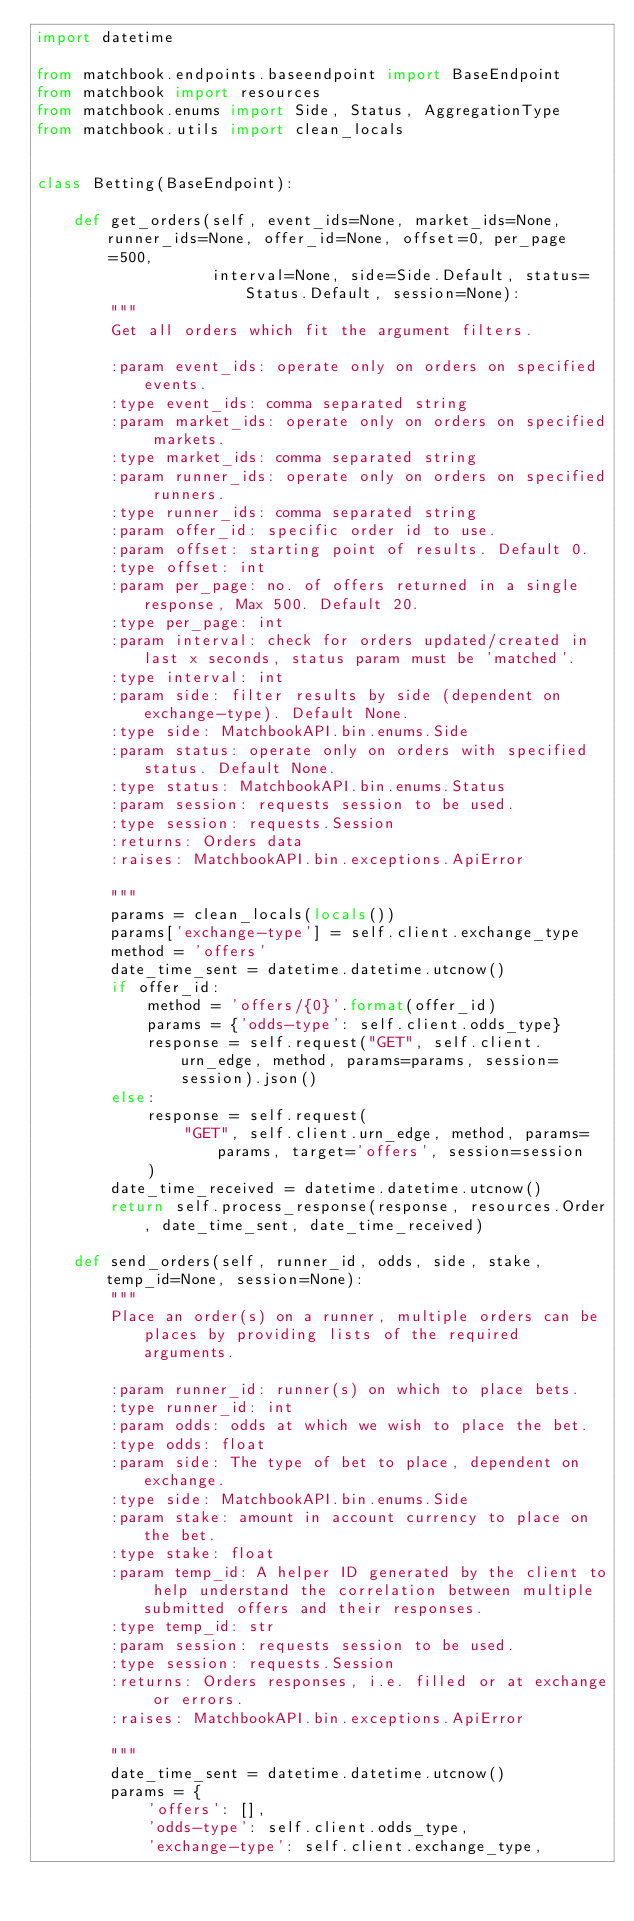Convert code to text. <code><loc_0><loc_0><loc_500><loc_500><_Python_>import datetime

from matchbook.endpoints.baseendpoint import BaseEndpoint
from matchbook import resources
from matchbook.enums import Side, Status, AggregationType
from matchbook.utils import clean_locals


class Betting(BaseEndpoint):

    def get_orders(self, event_ids=None, market_ids=None, runner_ids=None, offer_id=None, offset=0, per_page=500,
                   interval=None, side=Side.Default, status=Status.Default, session=None):
        """
        Get all orders which fit the argument filters.

        :param event_ids: operate only on orders on specified events.
        :type event_ids: comma separated string
        :param market_ids: operate only on orders on specified markets.
        :type market_ids: comma separated string
        :param runner_ids: operate only on orders on specified runners.
        :type runner_ids: comma separated string
        :param offer_id: specific order id to use.
        :param offset: starting point of results. Default 0.
        :type offset: int
        :param per_page: no. of offers returned in a single response, Max 500. Default 20.
        :type per_page: int
        :param interval: check for orders updated/created in last x seconds, status param must be 'matched'.
        :type interval: int
        :param side: filter results by side (dependent on exchange-type). Default None.
        :type side: MatchbookAPI.bin.enums.Side
        :param status: operate only on orders with specified status. Default None.
        :type status: MatchbookAPI.bin.enums.Status
        :param session: requests session to be used.
        :type session: requests.Session
        :returns: Orders data
        :raises: MatchbookAPI.bin.exceptions.ApiError

        """
        params = clean_locals(locals())
        params['exchange-type'] = self.client.exchange_type
        method = 'offers'
        date_time_sent = datetime.datetime.utcnow()
        if offer_id:
            method = 'offers/{0}'.format(offer_id)
            params = {'odds-type': self.client.odds_type}
            response = self.request("GET", self.client.urn_edge, method, params=params, session=session).json()
        else:
            response = self.request(
                "GET", self.client.urn_edge, method, params=params, target='offers', session=session
            )
        date_time_received = datetime.datetime.utcnow()
        return self.process_response(response, resources.Order, date_time_sent, date_time_received)

    def send_orders(self, runner_id, odds, side, stake, temp_id=None, session=None):
        """
        Place an order(s) on a runner, multiple orders can be places by providing lists of the required arguments.

        :param runner_id: runner(s) on which to place bets.
        :type runner_id: int
        :param odds: odds at which we wish to place the bet.
        :type odds: float
        :param side: The type of bet to place, dependent on exchange.
        :type side: MatchbookAPI.bin.enums.Side
        :param stake: amount in account currency to place on the bet.
        :type stake: float
        :param temp_id: A helper ID generated by the client to help understand the correlation between multiple submitted offers and their responses.
        :type temp_id: str
        :param session: requests session to be used.
        :type session: requests.Session
        :returns: Orders responses, i.e. filled or at exchange or errors.
        :raises: MatchbookAPI.bin.exceptions.ApiError

        """
        date_time_sent = datetime.datetime.utcnow()
        params = {
            'offers': [],
            'odds-type': self.client.odds_type,
            'exchange-type': self.client.exchange_type,</code> 